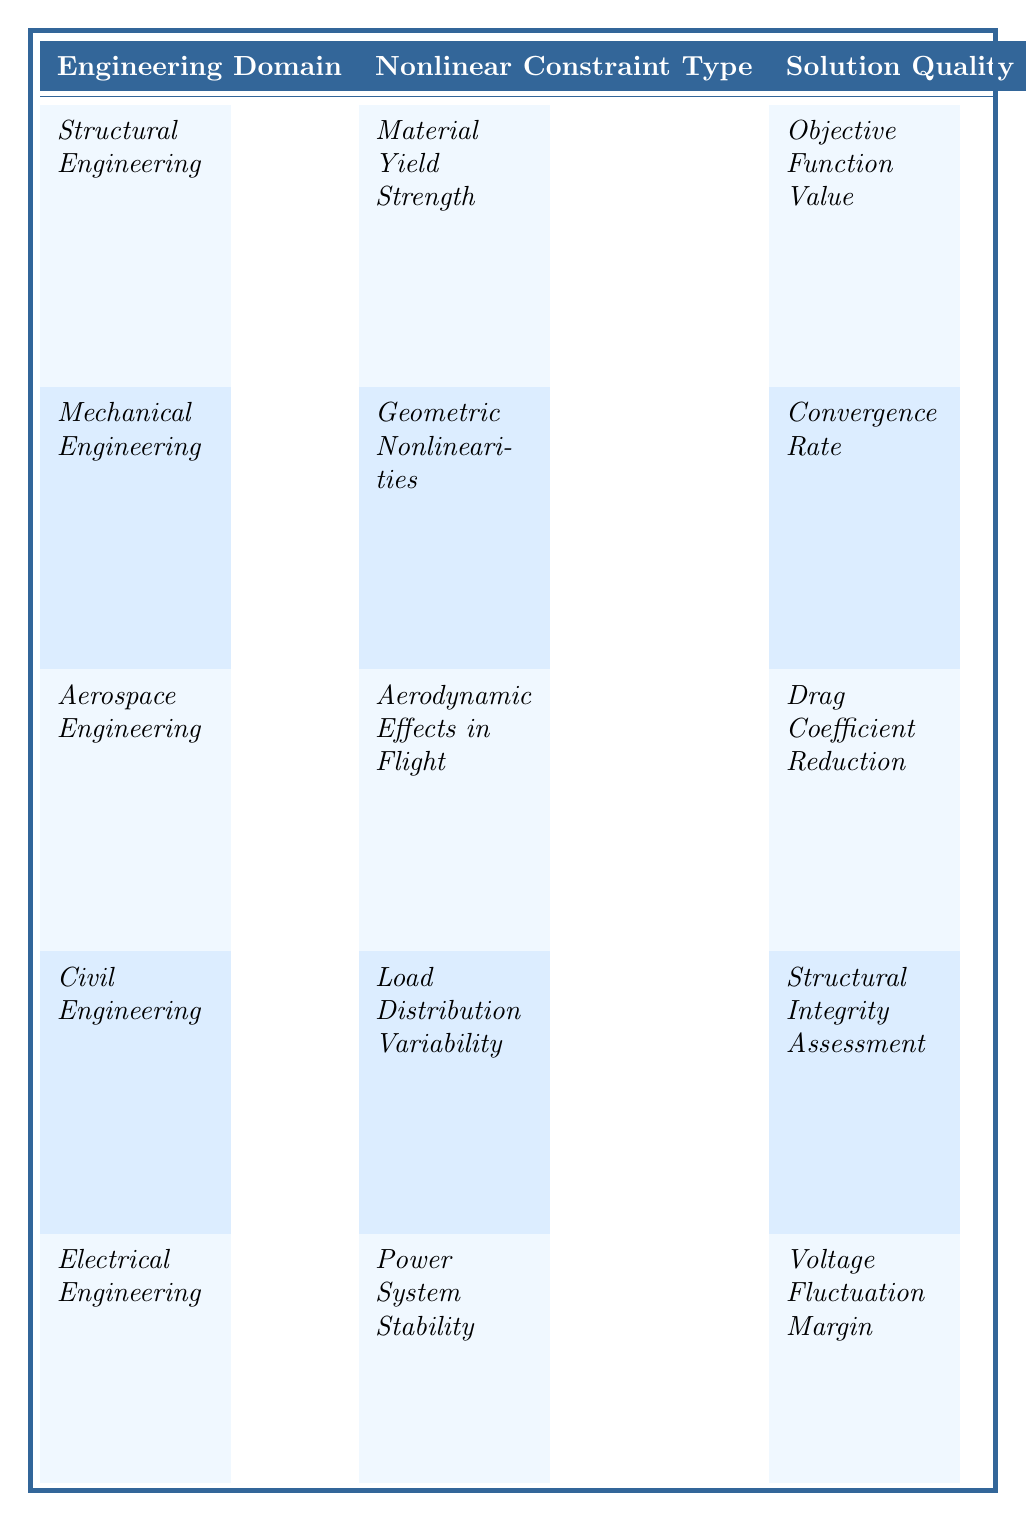What is the nonlinear constraint type in Structural Engineering? The table clearly indicates that for Structural Engineering, the nonlinear constraint type is Material Yield Strength. This information can be directly retrieved from the relevant row in the table.
Answer: Material Yield Strength How does the effect of nonlinear constraints in Mechanical Engineering compare to that in Civil Engineering? The table states that Mechanical Engineering has a nonlinear constraint effect of significantly slowing convergence by up to 30%, while Civil Engineering states that nonlinear load conditions lead to a higher incidence of structural failures. Thus, both impact solution quality significantly but in different ways: one affects the convergence rate and the other the failure rate.
Answer: Both have significant effects, but in different ways Which engineering domain reported a 15% increase in cost due to nonlinear constraints? According to the observations in the table, Structural Engineering reported a 15% increase in cost due to designs exceeding yield strength resulting from nonlinear constraints.
Answer: Structural Engineering What is the average increase in cost due to nonlinear constraints across the disciplines mentioned? The disciplines reporting cost impacts are Structural Engineering (15%), with no specific costs reported for others. Thus, averaging with only available data means 15% for one value and no increase for others; the average would still be 15% since there are no other values to consider.
Answer: 15% Do nonlinear geometric constraints in Mechanical Engineering cause faster or slower convergence? The information in the table specifies that nonlinear geometric constraints in Mechanical Engineering lead to slower convergence, by up to 30%. Therefore, the conclusion is that they cause slower convergence based on direct reference.
Answer: Slower convergence Which domain experiences the highest potential for accuracy improvement and what is that percentage? The table highlights that Aerospace Engineering experiences high-fidelity models that are 20% more accurate according to the nonlinear aerodynamic constraints mentioned. Thus, Aerospace Engineering has the highest potential accuracy improvement at this percentage.
Answer: 20% What is the key observation related to load distribution variability in Civil Engineering? The table indicates that the key observation for Civil Engineering related to load distribution variability is that models without nonlinear constraints had a 12% lower failure rate, directly stating the effect of these constraints on structural failure.
Answer: 12% lower failure rate If a design adjustment improves stability by 25% in Electrical Engineering, what is the implication of such adjustments? In Electrical Engineering, since the observation states that design adjustments can improve stability by approximately 25%, the implication is that incorporating these adjustments substantially enhances voltage fluctuation margins, indicating a strong impact on overall system performance.
Answer: Substantial improvement in stability What do both Aerospace and Civil Engineering have in common regarding the effects of nonlinear constraints? Both Aerospace Engineering and Civil Engineering describe that the nonlinear constraints lead to complications: Aerospace mentions complications in analysis and Civil mentions a higher incidence of structural failures, thus both domains face challenges introduced by nonlinear constraints.
Answer: They face complications from nonlinear constraints Is it true that nonlinear constraints in Mechanical Engineering require more iterations to achieve stable solutions? According to the table, the observation in Mechanical Engineering states that more iterations are indeed needed to achieve stable solutions due to nonlinear geometric constraints, hence this statement is true based on the provided data.
Answer: Yes, it is true 